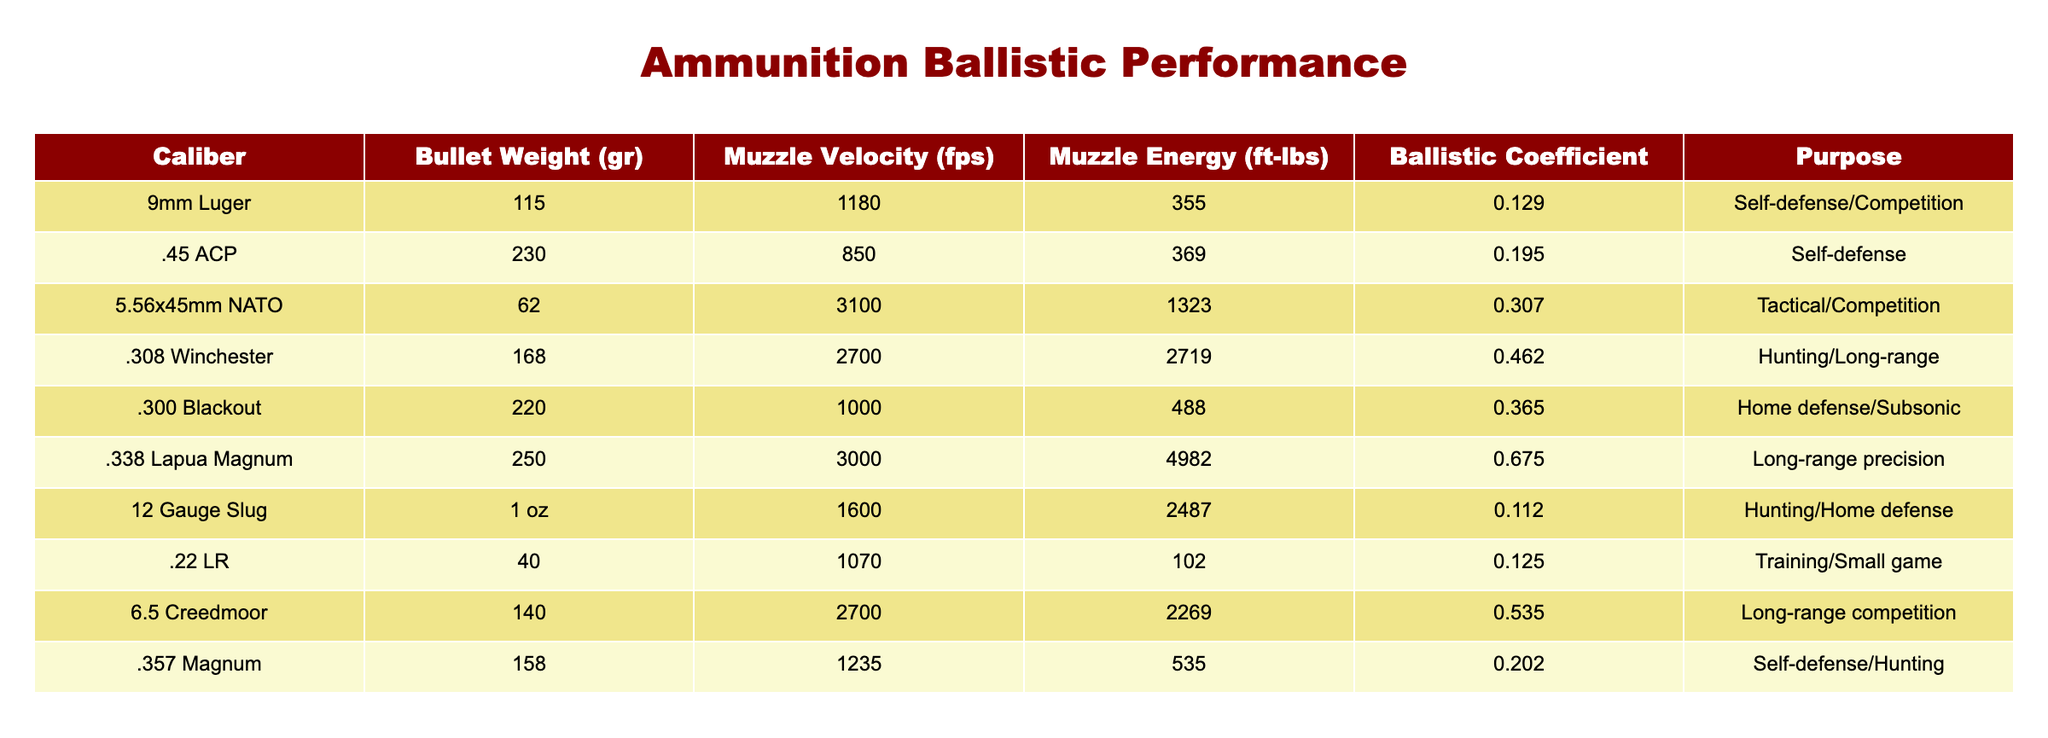What is the bullet weight of the 9mm Luger? The table lists the bullet weight for each caliber. For the 9mm Luger, it specifically shows 115 grains.
Answer: 115 gr Which ammunition type has the highest muzzle energy? By comparing the Muzzle Energy column, .338 Lapua Magnum with 4982 ft-lbs is the highest among all listed types.
Answer: .338 Lapua Magnum Is the .300 Blackout suitable for hunting? The table lists the purpose for each ammunition type. The .300 Blackout is labeled for Home defense/Subsonic, not specifically for hunting.
Answer: No What is the average muzzle velocity of the tactical/competition calibers? The tactical/competition calibers listed are 5.56x45mm NATO and 9mm Luger. Muzzle velocities are 3100 fps and 1180 fps, respectively. The average is (3100 + 1180) / 2 = 2140 fps.
Answer: 2140 fps Which caliber has a ballistic coefficient greater than 0.3? The table shows ballistic coefficients for each caliber. The calibers with a coefficient greater than 0.3 are 5.56x45mm NATO (0.307), .338 Lapua Magnum (0.675), and 6.5 Creedmoor (0.535).
Answer: 5.56x45mm NATO, .338 Lapua Magnum, 6.5 Creedmoor How much greater is the muzzle energy of .308 Winchester compared to .22 LR? The muzzle energy for .308 Winchester is 2719 ft-lbs, and for .22 LR it is 102 ft-lbs. The difference is 2719 - 102 = 2617 ft-lbs.
Answer: 2617 ft-lbs Does the .45 ACP have a higher muzzle velocity than the .22 LR? The .45 ACP has a muzzle velocity of 850 fps while the .22 LR has 1070 fps, thus the .45 ACP has a lower muzzle velocity.
Answer: No What is the purpose of the caliber with the second highest bullet weight? The caliber with the second highest bullet weight is .338 Lapua Magnum (250 gr), and its purpose is Long-range precision according to the table.
Answer: Long-range precision 